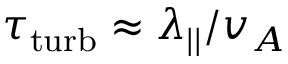<formula> <loc_0><loc_0><loc_500><loc_500>\tau _ { t u r b } \approx \lambda _ { | | } / v _ { A }</formula> 